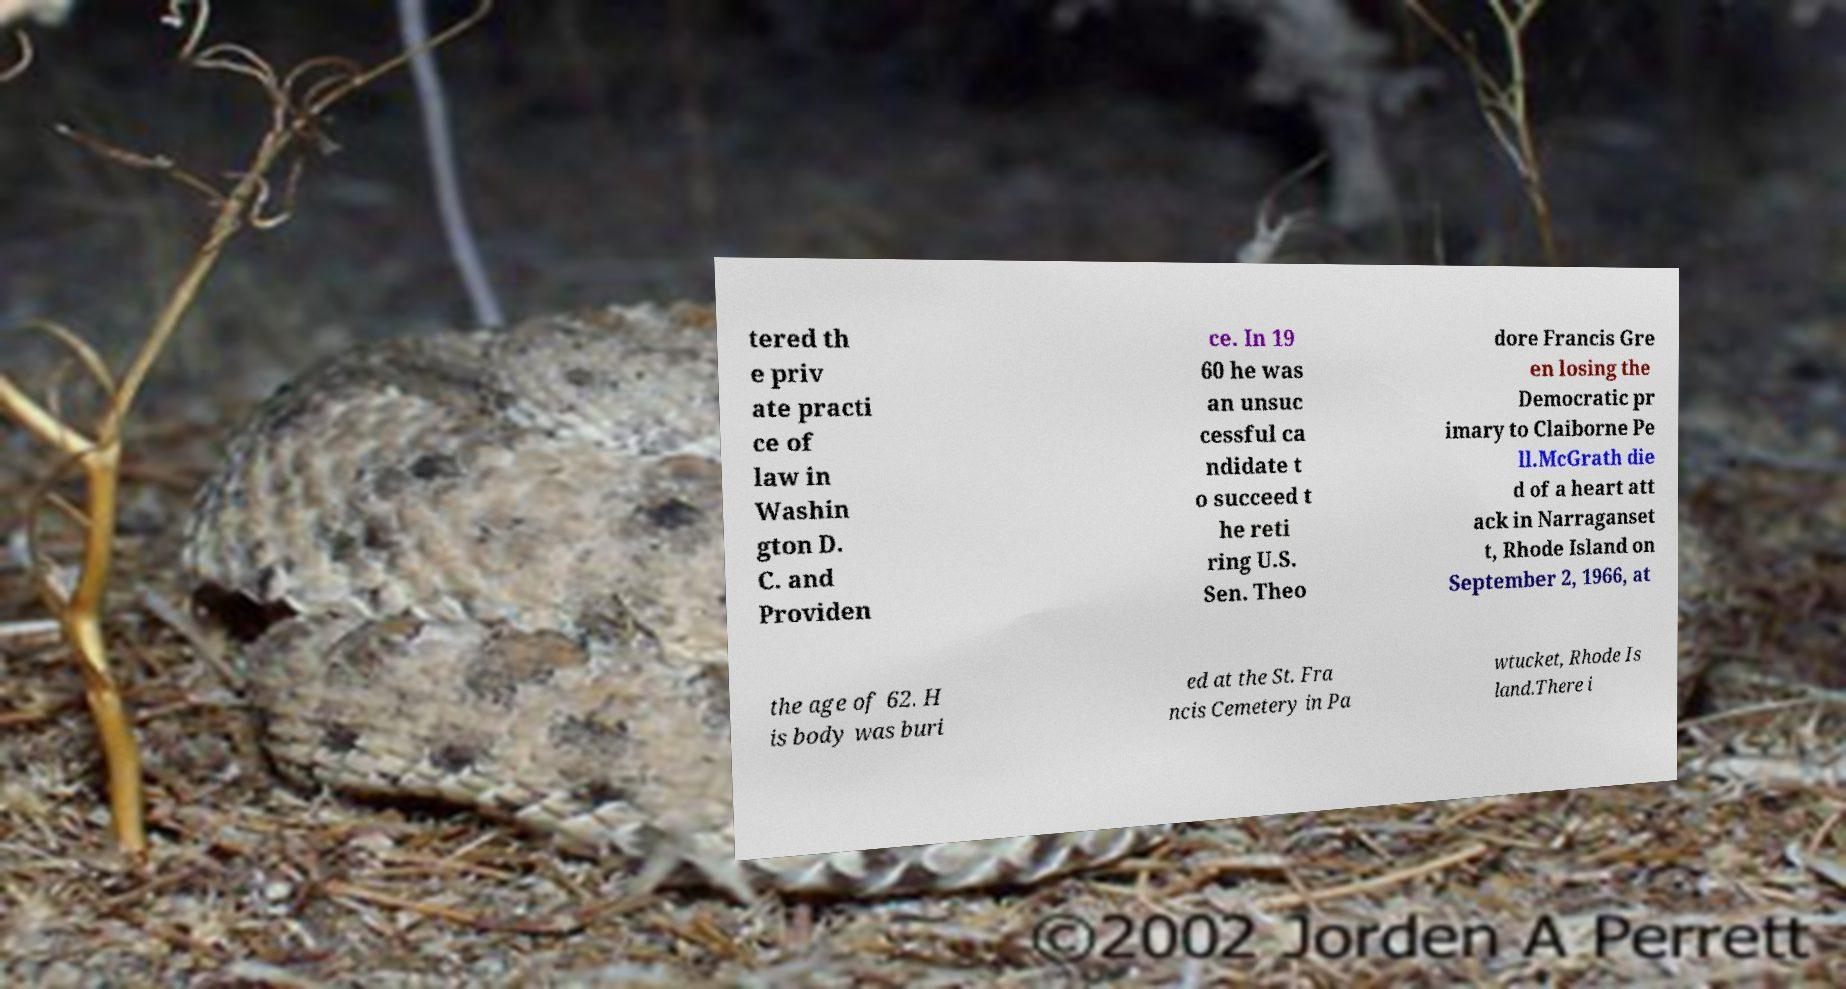Please read and relay the text visible in this image. What does it say? tered th e priv ate practi ce of law in Washin gton D. C. and Providen ce. In 19 60 he was an unsuc cessful ca ndidate t o succeed t he reti ring U.S. Sen. Theo dore Francis Gre en losing the Democratic pr imary to Claiborne Pe ll.McGrath die d of a heart att ack in Narraganset t, Rhode Island on September 2, 1966, at the age of 62. H is body was buri ed at the St. Fra ncis Cemetery in Pa wtucket, Rhode Is land.There i 